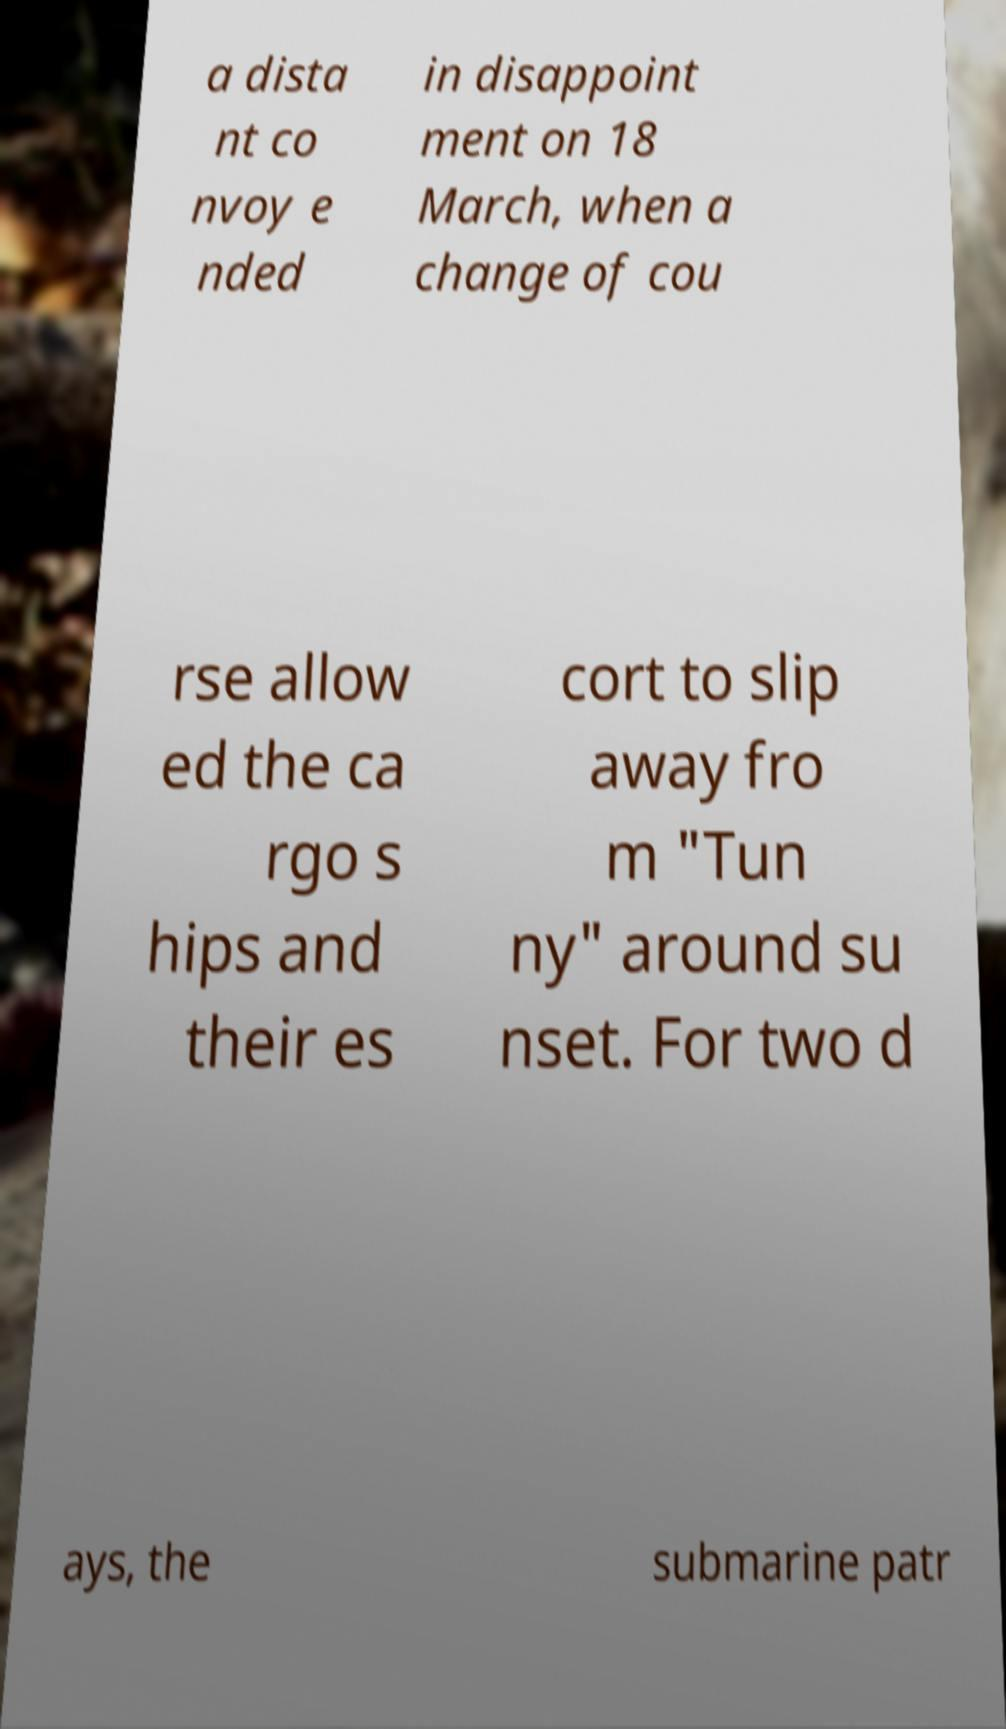What messages or text are displayed in this image? I need them in a readable, typed format. a dista nt co nvoy e nded in disappoint ment on 18 March, when a change of cou rse allow ed the ca rgo s hips and their es cort to slip away fro m "Tun ny" around su nset. For two d ays, the submarine patr 